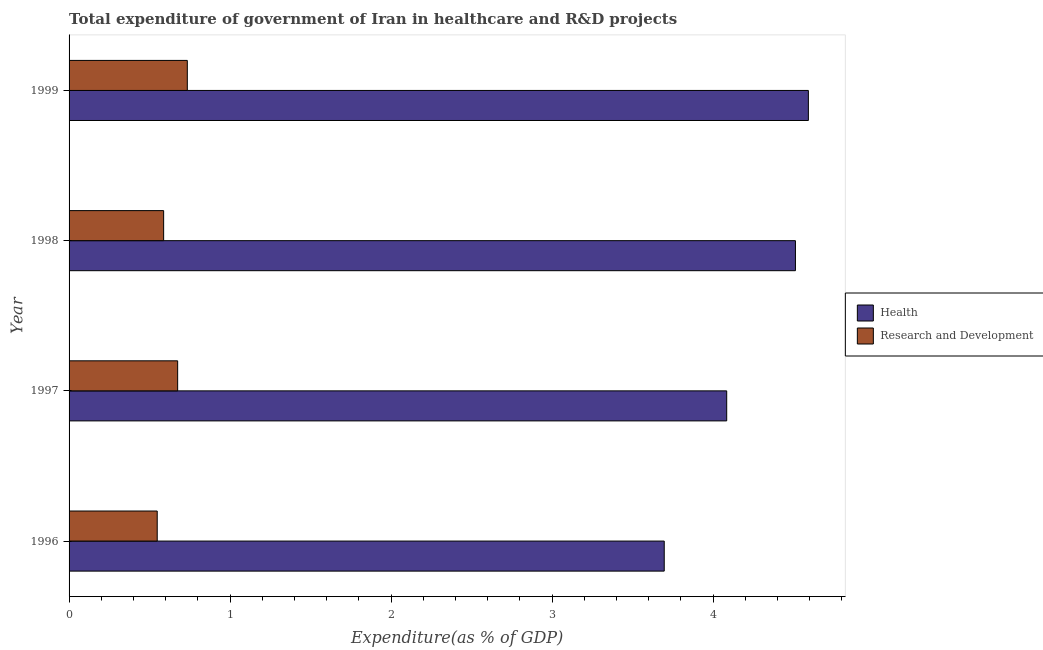How many groups of bars are there?
Provide a succinct answer. 4. How many bars are there on the 3rd tick from the top?
Keep it short and to the point. 2. What is the expenditure in healthcare in 1998?
Offer a terse response. 4.51. Across all years, what is the maximum expenditure in r&d?
Offer a terse response. 0.73. Across all years, what is the minimum expenditure in r&d?
Give a very brief answer. 0.55. In which year was the expenditure in healthcare maximum?
Your answer should be compact. 1999. In which year was the expenditure in healthcare minimum?
Make the answer very short. 1996. What is the total expenditure in r&d in the graph?
Give a very brief answer. 2.54. What is the difference between the expenditure in r&d in 1998 and that in 1999?
Your answer should be very brief. -0.15. What is the difference between the expenditure in r&d in 1997 and the expenditure in healthcare in 1996?
Ensure brevity in your answer.  -3.02. What is the average expenditure in r&d per year?
Keep it short and to the point. 0.64. In the year 1997, what is the difference between the expenditure in healthcare and expenditure in r&d?
Your answer should be very brief. 3.41. What is the ratio of the expenditure in healthcare in 1996 to that in 1999?
Your response must be concise. 0.81. Is the difference between the expenditure in r&d in 1996 and 1999 greater than the difference between the expenditure in healthcare in 1996 and 1999?
Your response must be concise. Yes. What is the difference between the highest and the second highest expenditure in r&d?
Provide a short and direct response. 0.06. What is the difference between the highest and the lowest expenditure in healthcare?
Give a very brief answer. 0.9. In how many years, is the expenditure in r&d greater than the average expenditure in r&d taken over all years?
Ensure brevity in your answer.  2. Is the sum of the expenditure in healthcare in 1998 and 1999 greater than the maximum expenditure in r&d across all years?
Your answer should be compact. Yes. What does the 2nd bar from the top in 1996 represents?
Your response must be concise. Health. What does the 2nd bar from the bottom in 1997 represents?
Offer a terse response. Research and Development. How many bars are there?
Your response must be concise. 8. Are all the bars in the graph horizontal?
Offer a very short reply. Yes. How many years are there in the graph?
Your answer should be very brief. 4. Does the graph contain any zero values?
Your answer should be compact. No. Does the graph contain grids?
Your answer should be very brief. No. How many legend labels are there?
Keep it short and to the point. 2. What is the title of the graph?
Offer a very short reply. Total expenditure of government of Iran in healthcare and R&D projects. What is the label or title of the X-axis?
Your response must be concise. Expenditure(as % of GDP). What is the Expenditure(as % of GDP) in Health in 1996?
Keep it short and to the point. 3.7. What is the Expenditure(as % of GDP) in Research and Development in 1996?
Your answer should be very brief. 0.55. What is the Expenditure(as % of GDP) of Health in 1997?
Offer a very short reply. 4.09. What is the Expenditure(as % of GDP) of Research and Development in 1997?
Give a very brief answer. 0.67. What is the Expenditure(as % of GDP) in Health in 1998?
Your response must be concise. 4.51. What is the Expenditure(as % of GDP) of Research and Development in 1998?
Your answer should be compact. 0.59. What is the Expenditure(as % of GDP) of Health in 1999?
Make the answer very short. 4.59. What is the Expenditure(as % of GDP) of Research and Development in 1999?
Ensure brevity in your answer.  0.73. Across all years, what is the maximum Expenditure(as % of GDP) of Health?
Offer a terse response. 4.59. Across all years, what is the maximum Expenditure(as % of GDP) in Research and Development?
Your answer should be very brief. 0.73. Across all years, what is the minimum Expenditure(as % of GDP) in Health?
Keep it short and to the point. 3.7. Across all years, what is the minimum Expenditure(as % of GDP) of Research and Development?
Provide a short and direct response. 0.55. What is the total Expenditure(as % of GDP) in Health in the graph?
Offer a terse response. 16.89. What is the total Expenditure(as % of GDP) in Research and Development in the graph?
Offer a very short reply. 2.54. What is the difference between the Expenditure(as % of GDP) in Health in 1996 and that in 1997?
Your answer should be compact. -0.39. What is the difference between the Expenditure(as % of GDP) of Research and Development in 1996 and that in 1997?
Provide a short and direct response. -0.13. What is the difference between the Expenditure(as % of GDP) in Health in 1996 and that in 1998?
Give a very brief answer. -0.81. What is the difference between the Expenditure(as % of GDP) in Research and Development in 1996 and that in 1998?
Make the answer very short. -0.04. What is the difference between the Expenditure(as % of GDP) in Health in 1996 and that in 1999?
Offer a very short reply. -0.9. What is the difference between the Expenditure(as % of GDP) in Research and Development in 1996 and that in 1999?
Offer a very short reply. -0.19. What is the difference between the Expenditure(as % of GDP) in Health in 1997 and that in 1998?
Your response must be concise. -0.43. What is the difference between the Expenditure(as % of GDP) in Research and Development in 1997 and that in 1998?
Provide a short and direct response. 0.09. What is the difference between the Expenditure(as % of GDP) of Health in 1997 and that in 1999?
Your answer should be very brief. -0.51. What is the difference between the Expenditure(as % of GDP) of Research and Development in 1997 and that in 1999?
Your answer should be compact. -0.06. What is the difference between the Expenditure(as % of GDP) in Health in 1998 and that in 1999?
Keep it short and to the point. -0.08. What is the difference between the Expenditure(as % of GDP) of Research and Development in 1998 and that in 1999?
Keep it short and to the point. -0.15. What is the difference between the Expenditure(as % of GDP) of Health in 1996 and the Expenditure(as % of GDP) of Research and Development in 1997?
Provide a short and direct response. 3.02. What is the difference between the Expenditure(as % of GDP) in Health in 1996 and the Expenditure(as % of GDP) in Research and Development in 1998?
Ensure brevity in your answer.  3.11. What is the difference between the Expenditure(as % of GDP) in Health in 1996 and the Expenditure(as % of GDP) in Research and Development in 1999?
Your answer should be compact. 2.96. What is the difference between the Expenditure(as % of GDP) of Health in 1997 and the Expenditure(as % of GDP) of Research and Development in 1998?
Offer a very short reply. 3.5. What is the difference between the Expenditure(as % of GDP) of Health in 1997 and the Expenditure(as % of GDP) of Research and Development in 1999?
Offer a terse response. 3.35. What is the difference between the Expenditure(as % of GDP) of Health in 1998 and the Expenditure(as % of GDP) of Research and Development in 1999?
Provide a short and direct response. 3.78. What is the average Expenditure(as % of GDP) of Health per year?
Provide a succinct answer. 4.22. What is the average Expenditure(as % of GDP) of Research and Development per year?
Make the answer very short. 0.64. In the year 1996, what is the difference between the Expenditure(as % of GDP) of Health and Expenditure(as % of GDP) of Research and Development?
Offer a very short reply. 3.15. In the year 1997, what is the difference between the Expenditure(as % of GDP) of Health and Expenditure(as % of GDP) of Research and Development?
Ensure brevity in your answer.  3.41. In the year 1998, what is the difference between the Expenditure(as % of GDP) of Health and Expenditure(as % of GDP) of Research and Development?
Ensure brevity in your answer.  3.92. In the year 1999, what is the difference between the Expenditure(as % of GDP) of Health and Expenditure(as % of GDP) of Research and Development?
Your answer should be compact. 3.86. What is the ratio of the Expenditure(as % of GDP) in Health in 1996 to that in 1997?
Provide a short and direct response. 0.91. What is the ratio of the Expenditure(as % of GDP) in Research and Development in 1996 to that in 1997?
Your answer should be compact. 0.81. What is the ratio of the Expenditure(as % of GDP) of Health in 1996 to that in 1998?
Your response must be concise. 0.82. What is the ratio of the Expenditure(as % of GDP) of Research and Development in 1996 to that in 1998?
Offer a very short reply. 0.93. What is the ratio of the Expenditure(as % of GDP) in Health in 1996 to that in 1999?
Ensure brevity in your answer.  0.81. What is the ratio of the Expenditure(as % of GDP) of Research and Development in 1996 to that in 1999?
Offer a very short reply. 0.75. What is the ratio of the Expenditure(as % of GDP) in Health in 1997 to that in 1998?
Your answer should be very brief. 0.91. What is the ratio of the Expenditure(as % of GDP) in Research and Development in 1997 to that in 1998?
Your answer should be compact. 1.15. What is the ratio of the Expenditure(as % of GDP) in Health in 1997 to that in 1999?
Offer a very short reply. 0.89. What is the ratio of the Expenditure(as % of GDP) in Research and Development in 1997 to that in 1999?
Your answer should be compact. 0.92. What is the ratio of the Expenditure(as % of GDP) in Health in 1998 to that in 1999?
Provide a short and direct response. 0.98. What is the ratio of the Expenditure(as % of GDP) of Research and Development in 1998 to that in 1999?
Provide a succinct answer. 0.8. What is the difference between the highest and the second highest Expenditure(as % of GDP) in Health?
Offer a terse response. 0.08. What is the difference between the highest and the lowest Expenditure(as % of GDP) of Health?
Your answer should be compact. 0.9. What is the difference between the highest and the lowest Expenditure(as % of GDP) of Research and Development?
Keep it short and to the point. 0.19. 